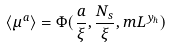<formula> <loc_0><loc_0><loc_500><loc_500>\langle \mu ^ { a } \rangle = \Phi ( \frac { a } { \xi } , \frac { N _ { s } } { \xi } , m L ^ { y _ { h } } )</formula> 